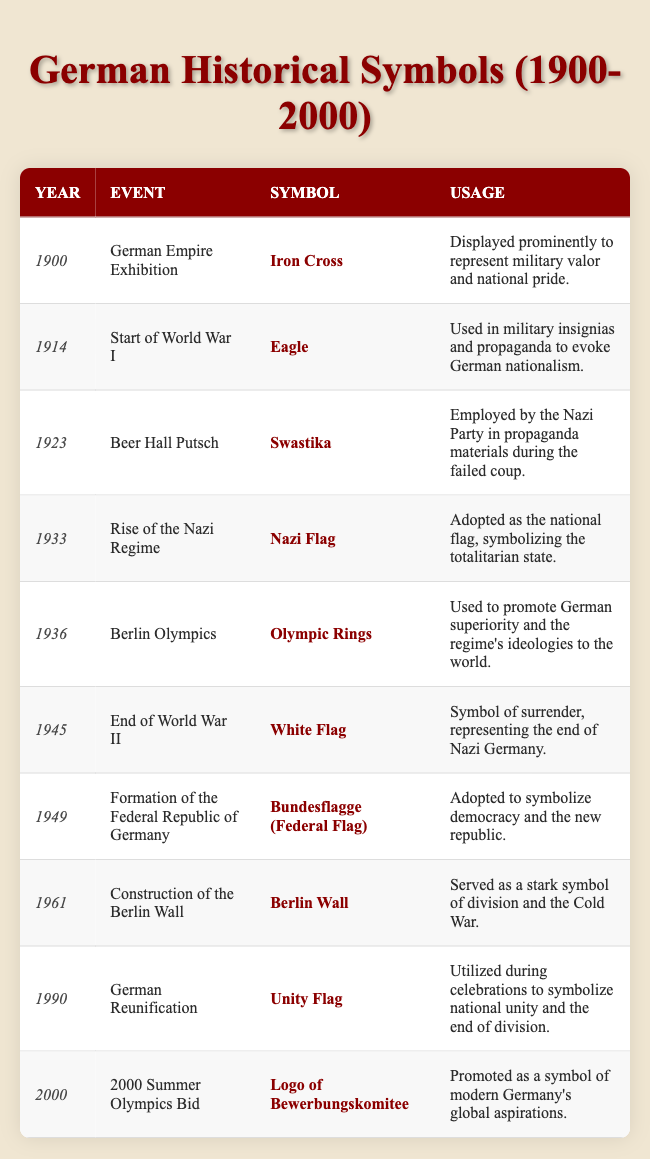What symbol was used during the Berlin Olympics? The table shows that the symbol used during the Berlin Olympics in 1936 was the Olympic Rings.
Answer: Olympic Rings Which event corresponds to the usage of the Iron Cross? According to the table, the Iron Cross was prominently displayed during the German Empire Exhibition in 1900.
Answer: German Empire Exhibition In what year was the White Flag used, and what did it symbolize? The table states that the White Flag was used in 1945 as a symbol of surrender, representing the end of Nazi Germany.
Answer: 1945; symbol of surrender How many different symbols were used between 1900 and 2000? Counting the distinct symbols listed in the table from each event between 1900 and 2000, there are 10 unique symbols.
Answer: 10 True or False: The Swastika was used as a symbol of celebration during the Beer Hall Putsch. The table indicates that the Swastika was employed by the Nazi Party in propaganda materials during the Beer Hall Putsch in 1923, not as a symbol of celebration.
Answer: False What was the event that led to the adoption of the Bundesflagge? The table notes that the Bundesflagge, or Federal Flag, was adopted during the formation of the Federal Republic of Germany in 1949.
Answer: Formation of the Federal Republic of Germany During which national event was the Unity Flag utilized, and what did it represent? The table shows that the Unity Flag was utilized during the German Reunification in 1990, symbolizing national unity and the end of division.
Answer: German Reunification; national unity Which two events occurred within two decades of each other and utilized symbols representing division? The table indicates that the Berlin Wall was constructed in 1961 and served as a symbol of division, while the event of German Reunification in 1990 highlighted the end of that division, therefore spanning these two decades of contrasting symbols.
Answer: Berlin Wall construction (1961) and German Reunification (1990) What is the difference in years between the start of World War I and the end of World War II? The start of World War I was in 1914 and the end of World War II was in 1945. Calculating the difference gives 1945 - 1914 = 31 years.
Answer: 31 years Which symbol was used for military purposes and what was its significance? The Eagle was used in military insignias and propaganda during the start of World War I in 1914, evoking German nationalism.
Answer: Eagle; evoked German nationalism 